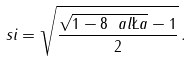Convert formula to latex. <formula><loc_0><loc_0><loc_500><loc_500>\ s i = \sqrt { \frac { \sqrt { 1 - 8 \ a l \L a } - 1 } { 2 } } \, .</formula> 